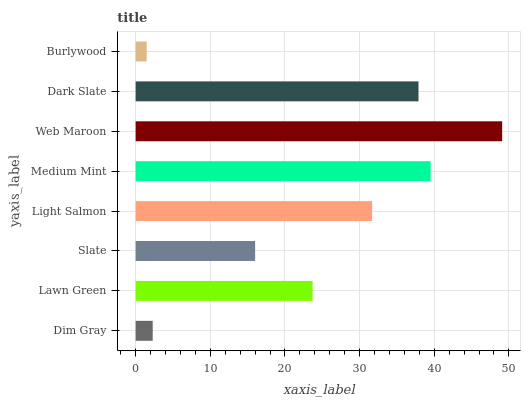Is Burlywood the minimum?
Answer yes or no. Yes. Is Web Maroon the maximum?
Answer yes or no. Yes. Is Lawn Green the minimum?
Answer yes or no. No. Is Lawn Green the maximum?
Answer yes or no. No. Is Lawn Green greater than Dim Gray?
Answer yes or no. Yes. Is Dim Gray less than Lawn Green?
Answer yes or no. Yes. Is Dim Gray greater than Lawn Green?
Answer yes or no. No. Is Lawn Green less than Dim Gray?
Answer yes or no. No. Is Light Salmon the high median?
Answer yes or no. Yes. Is Lawn Green the low median?
Answer yes or no. Yes. Is Dim Gray the high median?
Answer yes or no. No. Is Slate the low median?
Answer yes or no. No. 